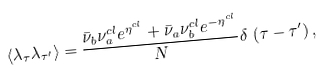Convert formula to latex. <formula><loc_0><loc_0><loc_500><loc_500>\left < { \lambda } _ { \tau } { \lambda } _ { { \tau } ^ { \prime } } \right > = \frac { { \bar { \nu } } _ { b } { \nu } _ { a } ^ { c l } e ^ { { \eta } ^ { c l } } + { \bar { \nu } } _ { a } { \nu } _ { b } ^ { c l } e ^ { - { \eta } ^ { c l } } } { N } \delta \, \left ( \tau - { \tau } ^ { \prime } \right ) ,</formula> 